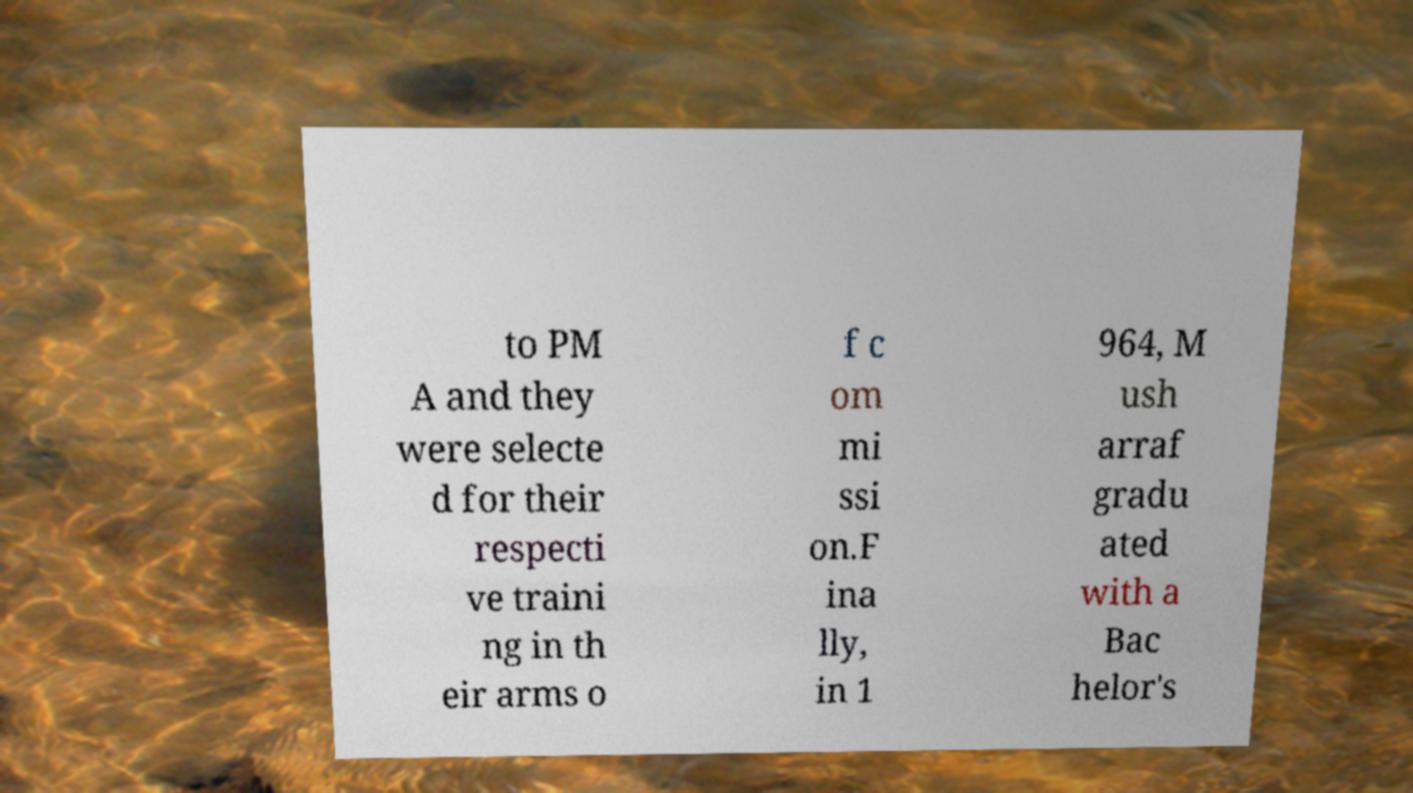Can you read and provide the text displayed in the image?This photo seems to have some interesting text. Can you extract and type it out for me? to PM A and they were selecte d for their respecti ve traini ng in th eir arms o f c om mi ssi on.F ina lly, in 1 964, M ush arraf gradu ated with a Bac helor's 